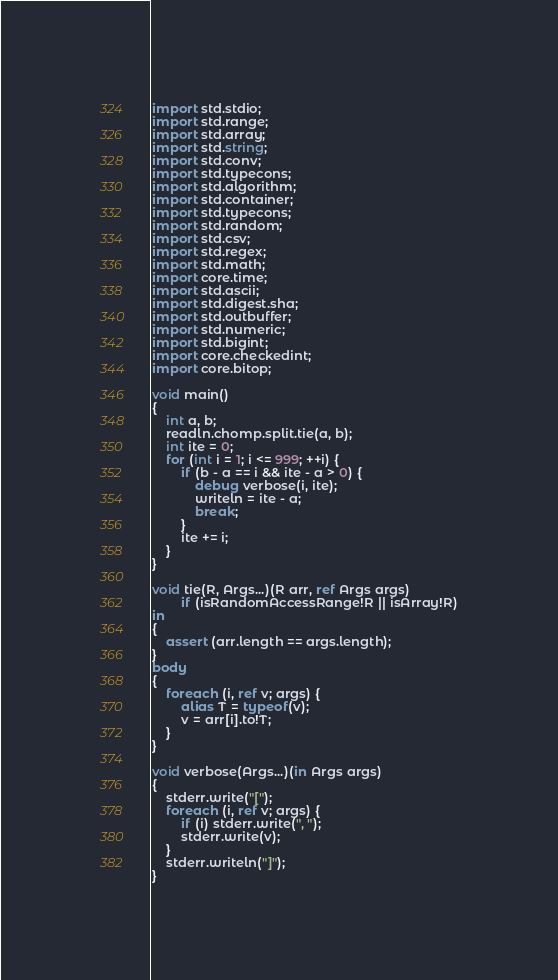Convert code to text. <code><loc_0><loc_0><loc_500><loc_500><_D_>import std.stdio;
import std.range;
import std.array;
import std.string;
import std.conv;
import std.typecons;
import std.algorithm;
import std.container;
import std.typecons;
import std.random;
import std.csv;
import std.regex;
import std.math;
import core.time;
import std.ascii;
import std.digest.sha;
import std.outbuffer;
import std.numeric;
import std.bigint;
import core.checkedint;
import core.bitop;

void main()
{
	int a, b;
	readln.chomp.split.tie(a, b);
	int ite = 0;
	for (int i = 1; i <= 999; ++i) {
		if (b - a == i && ite - a > 0) {
			debug verbose(i, ite);
			writeln = ite - a;
			break;
		}
		ite += i;
	}
}

void tie(R, Args...)(R arr, ref Args args)
		if (isRandomAccessRange!R || isArray!R)
in
{
	assert (arr.length == args.length);
}
body
{
	foreach (i, ref v; args) {
		alias T = typeof(v);
		v = arr[i].to!T;
	}
}

void verbose(Args...)(in Args args)
{
	stderr.write("[");
	foreach (i, ref v; args) {
		if (i) stderr.write(", ");
		stderr.write(v);
	}
	stderr.writeln("]");
}
</code> 